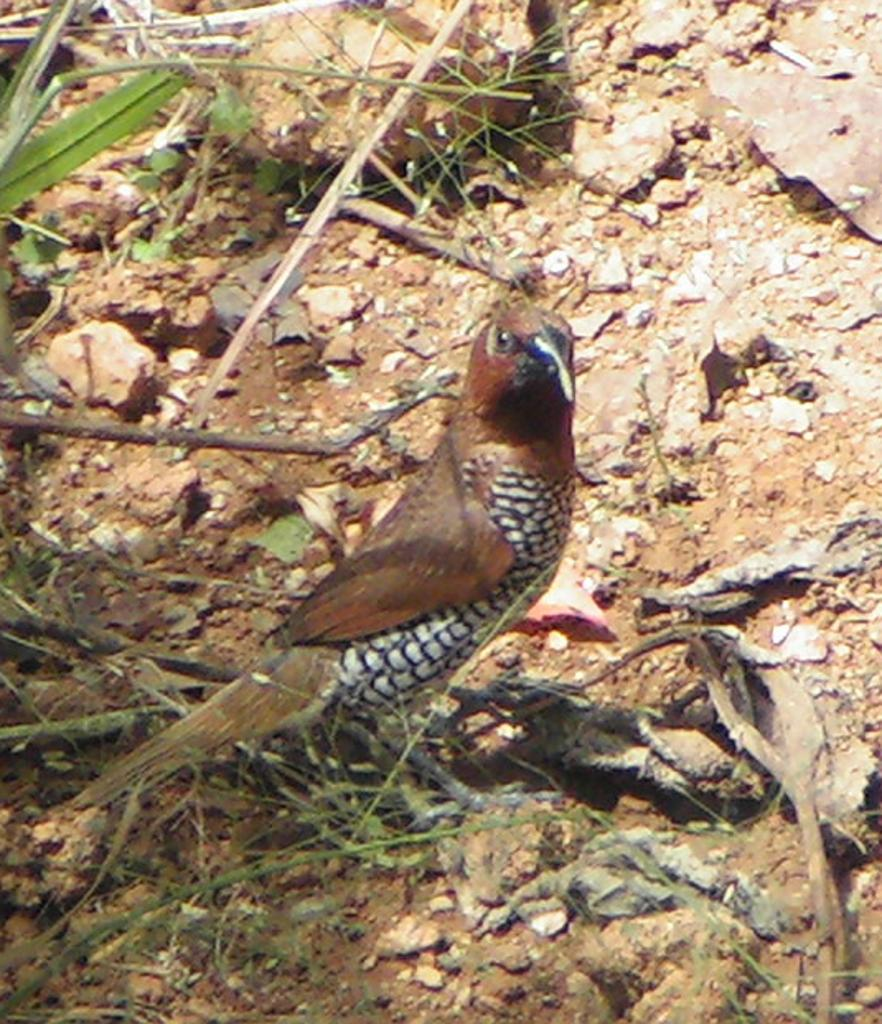What type of animal is present in the image? There is a bird in the image. Where is the bird located? The bird is standing on the ground. What else can be seen on the ground in the image? There are stones and small plants on the ground. Can you see an airplane flying over the bird in the image? There is no airplane present in the image. Is there an arch visible in the background of the image? There is no arch present in the image. 